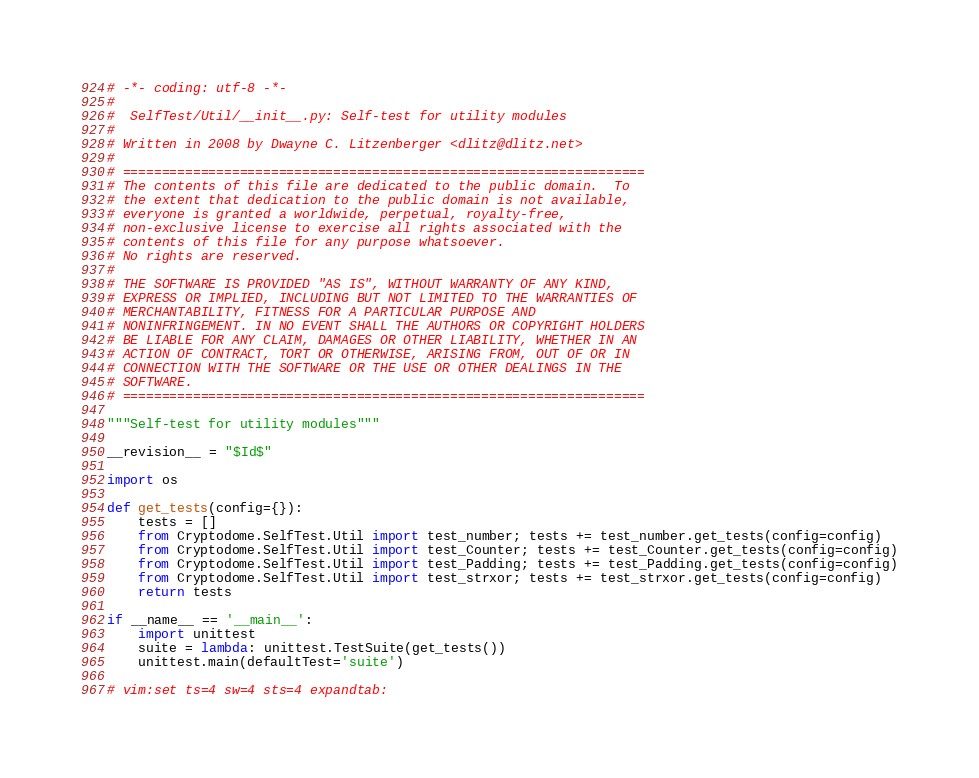Convert code to text. <code><loc_0><loc_0><loc_500><loc_500><_Python_># -*- coding: utf-8 -*-
#
#  SelfTest/Util/__init__.py: Self-test for utility modules
#
# Written in 2008 by Dwayne C. Litzenberger <dlitz@dlitz.net>
#
# ===================================================================
# The contents of this file are dedicated to the public domain.  To
# the extent that dedication to the public domain is not available,
# everyone is granted a worldwide, perpetual, royalty-free,
# non-exclusive license to exercise all rights associated with the
# contents of this file for any purpose whatsoever.
# No rights are reserved.
#
# THE SOFTWARE IS PROVIDED "AS IS", WITHOUT WARRANTY OF ANY KIND,
# EXPRESS OR IMPLIED, INCLUDING BUT NOT LIMITED TO THE WARRANTIES OF
# MERCHANTABILITY, FITNESS FOR A PARTICULAR PURPOSE AND
# NONINFRINGEMENT. IN NO EVENT SHALL THE AUTHORS OR COPYRIGHT HOLDERS
# BE LIABLE FOR ANY CLAIM, DAMAGES OR OTHER LIABILITY, WHETHER IN AN
# ACTION OF CONTRACT, TORT OR OTHERWISE, ARISING FROM, OUT OF OR IN
# CONNECTION WITH THE SOFTWARE OR THE USE OR OTHER DEALINGS IN THE
# SOFTWARE.
# ===================================================================

"""Self-test for utility modules"""

__revision__ = "$Id$"

import os

def get_tests(config={}):
    tests = []
    from Cryptodome.SelfTest.Util import test_number; tests += test_number.get_tests(config=config)
    from Cryptodome.SelfTest.Util import test_Counter; tests += test_Counter.get_tests(config=config)
    from Cryptodome.SelfTest.Util import test_Padding; tests += test_Padding.get_tests(config=config)
    from Cryptodome.SelfTest.Util import test_strxor; tests += test_strxor.get_tests(config=config)
    return tests

if __name__ == '__main__':
    import unittest
    suite = lambda: unittest.TestSuite(get_tests())
    unittest.main(defaultTest='suite')

# vim:set ts=4 sw=4 sts=4 expandtab:
</code> 